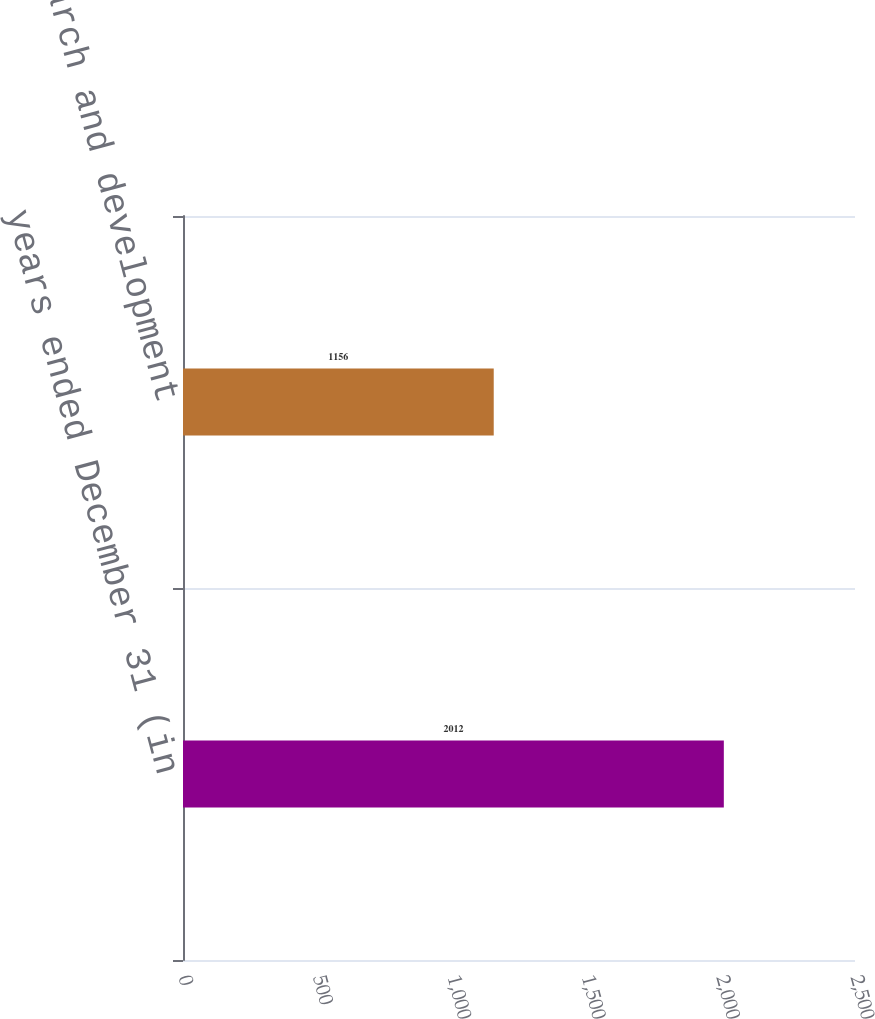Convert chart. <chart><loc_0><loc_0><loc_500><loc_500><bar_chart><fcel>years ended December 31 (in<fcel>Research and development<nl><fcel>2012<fcel>1156<nl></chart> 